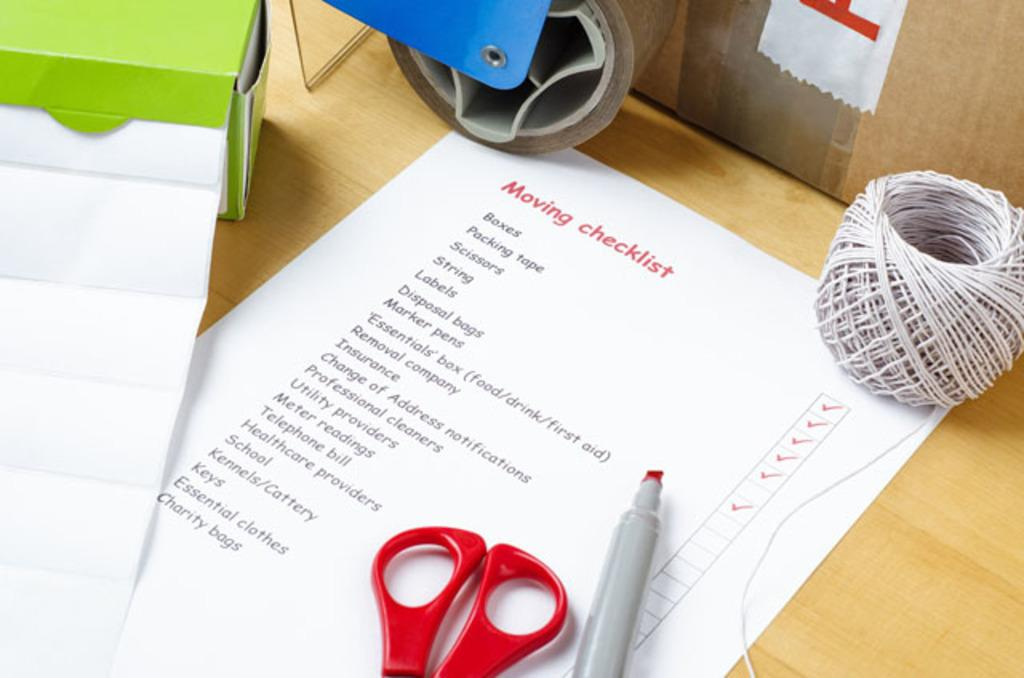What is on the table in the image? There is a paper, a pen, a pair of scissors, a cotton box, a wire, and a plaster on the table. What else can be seen beside the table? There is another cotton box beside the table. What might be used for writing in the image? The pen on the table might be used for writing. What could be used for cutting in the image? The pair of scissors on the table could be used for cutting. How many trucks are parked in front of the table in the image? There are no trucks visible in the image; it only shows objects on a table. What type of skin is being treated with the plaster in the image? There is no skin being treated in the image; it only shows a plaster on the table. 